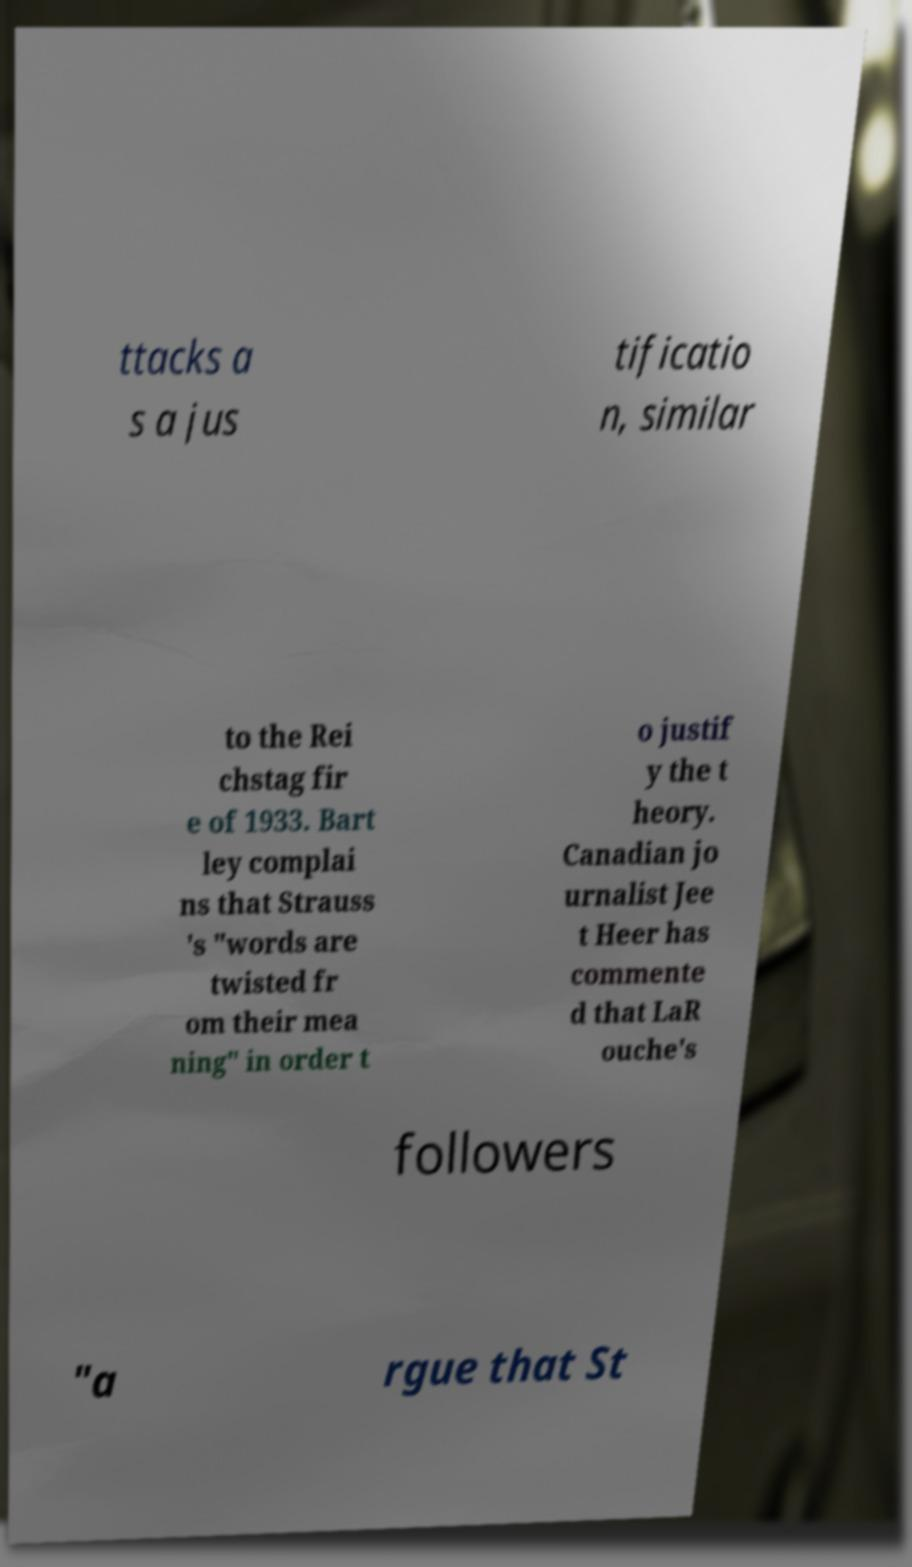Could you extract and type out the text from this image? ttacks a s a jus tificatio n, similar to the Rei chstag fir e of 1933. Bart ley complai ns that Strauss 's "words are twisted fr om their mea ning" in order t o justif y the t heory. Canadian jo urnalist Jee t Heer has commente d that LaR ouche's followers "a rgue that St 